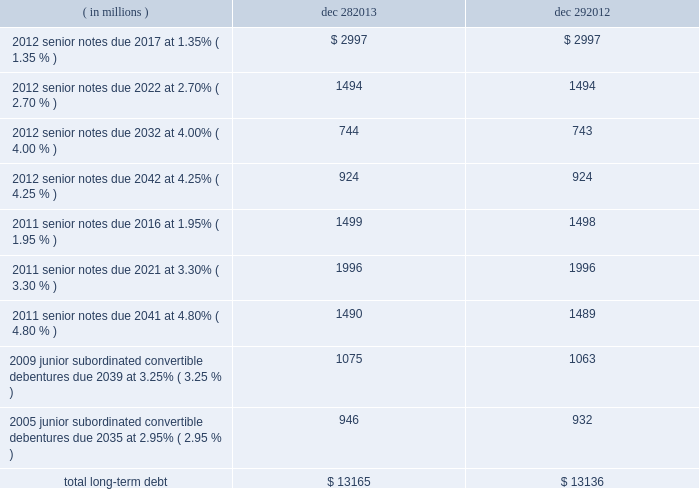Note 15 : chipset design issue in january 2011 , as part of our ongoing quality assurance procedures , we identified a design issue with the intel ae 6 series express chipset family .
The issue affected chipsets sold in the fourth quarter of 2010 and january 2011 .
We subsequently implemented a silicon fix and began shipping the updated version of the affected chipset in february 2011 .
The total cost in 2011 to repair and replace affected materials and systems , located with customers and in the market , was $ 422 million .
We do not expect to have any significant future adjustments related to this issue .
Note 16 : borrowings short-term debt as of december 28 , 2013 , short-term debt consisted of drafts payable of $ 257 million and notes payable of $ 24 million ( drafts payable of $ 264 million and notes payable of $ 48 million as of december 29 , 2012 ) .
We have an ongoing authorization from our board of directors to borrow up to $ 3.0 billion , including through the issuance of commercial paper .
Maximum borrowings under our commercial paper program during 2013 were $ 300 million ( $ 500 million during 2012 ) .
Our commercial paper was rated a-1+ by standard & poor 2019s and p-1 by moody 2019s as of december 28 , 2013 .
Long-term debt our long-term debt at the end of each period was as follows : ( in millions ) dec 28 , dec 29 .
Senior notes in the fourth quarter of 2012 , we issued $ 6.2 billion aggregate principal amount of senior unsecured notes for general corporate purposes and to repurchase shares of our common stock pursuant to our authorized common stock repurchase program .
In the third quarter of 2011 , we issued $ 5.0 billion aggregate principal amount of senior unsecured notes , primarily to repurchase shares of our common stock pursuant to our authorized common stock repurchase program , and for general corporate purposes .
Our senior notes pay a fixed rate of interest semiannually .
We may redeem our senior notes , in whole or in part , at any time at our option at specified redemption prices .
The senior notes rank equally in right of payment with all of our other existing and future senior unsecured indebtedness and will effectively rank junior to all liabilities of our subsidiaries .
Table of contents intel corporation notes to consolidated financial statements ( continued ) .
What is the net cash flow from short-term debt in 2013? 
Computations: ((257 + 24) - (264 + 48))
Answer: -31.0. 